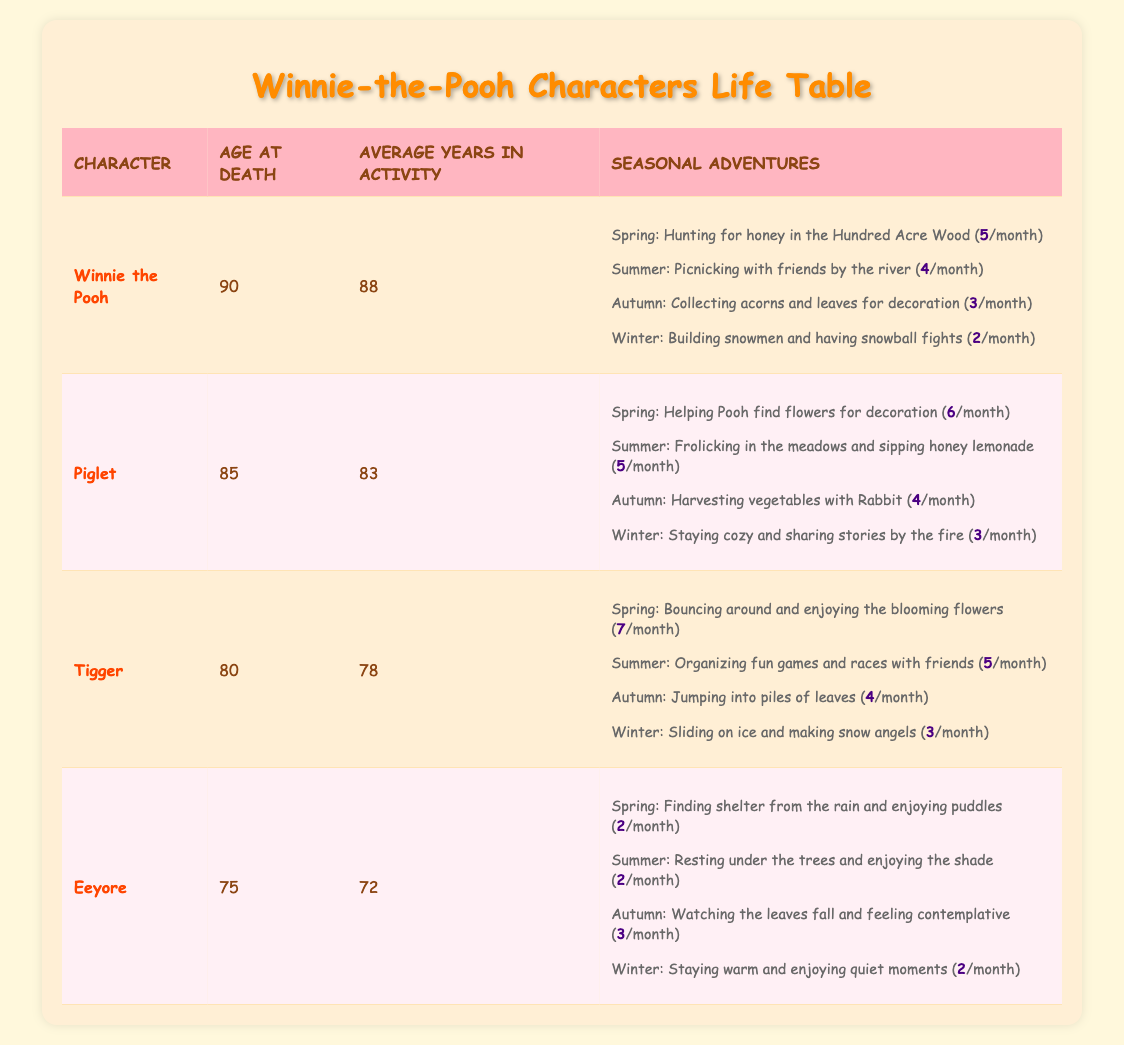What is the age at death of Tigger? The table lists Tigger's age at death directly in the second column. It shows that Tigger's age at death is 80.
Answer: 80 How many seasonal adventures does Piglet have in total? To find the total number of seasonal adventures, we look at the monthly frequency of each season for Piglet: Spring (6), Summer (5), Autumn (4), and Winter (3). Summing these gives us 6 + 5 + 4 + 3 = 18.
Answer: 18 Is Eeyore's average years in activity greater than 75? The table states Eeyore's average years in activity is 72, which is less than 75. Thus, the statement is false.
Answer: No What is the difference in age at death between Winnie the Pooh and Piglet? To find the difference, we subtract Piglet's age at death from Winnie the Pooh's age at death: 90 - 85 = 5.
Answer: 5 Which character participates in seasonal adventures the most in Spring? Looking at the table, Tigger has the highest monthly frequency in Spring with 7 adventures, while Winnie the Pooh follows with 5, Piglet with 6, and Eeyore with 2.
Answer: Tigger How many adventures does each character have during Winter? For Winter, the monthly frequencies for each character are: Winnie the Pooh (2), Piglet (3), Tigger (3), and Eeyore (2). Adding these, we find 2 + 3 + 3 + 2 = 10 adventures total during Winter.
Answer: 10 Does Winnie the Pooh have more seasonal adventures in Summer than Eeyore has in Spring? Winnie the Pooh has 4 adventures in Summer while Eeyore has 2 adventures in Spring. Since 4 is greater than 2, the answer is yes.
Answer: Yes Who has the longest average years in activity? A quick glance at the 'Average Years in Activity' column shows that Winnie the Pooh has 88 years, which is more than Piglet (83), Tigger (78), and Eeyore (72).
Answer: Winnie the Pooh 